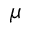Convert formula to latex. <formula><loc_0><loc_0><loc_500><loc_500>\mu</formula> 